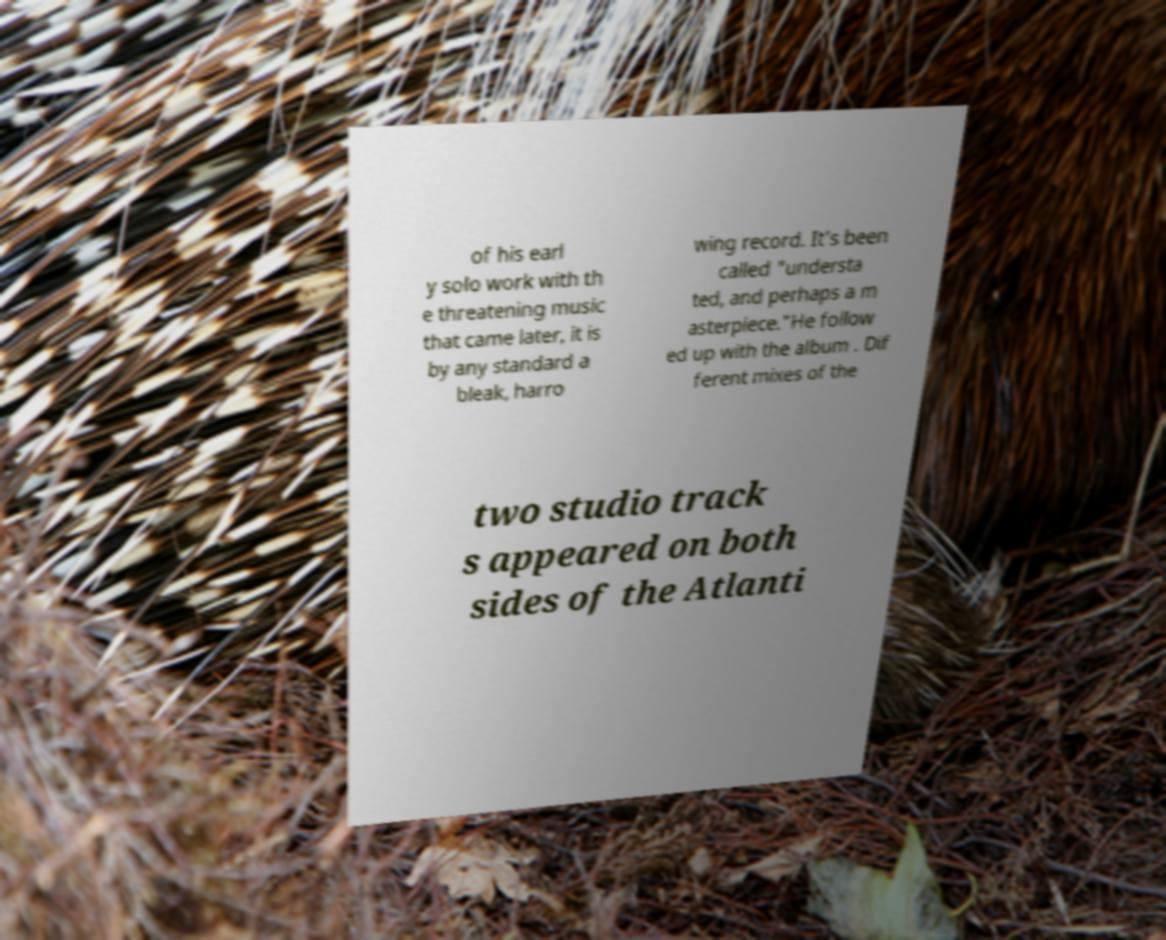For documentation purposes, I need the text within this image transcribed. Could you provide that? of his earl y solo work with th e threatening music that came later, it is by any standard a bleak, harro wing record. It's been called "understa ted, and perhaps a m asterpiece."He follow ed up with the album . Dif ferent mixes of the two studio track s appeared on both sides of the Atlanti 